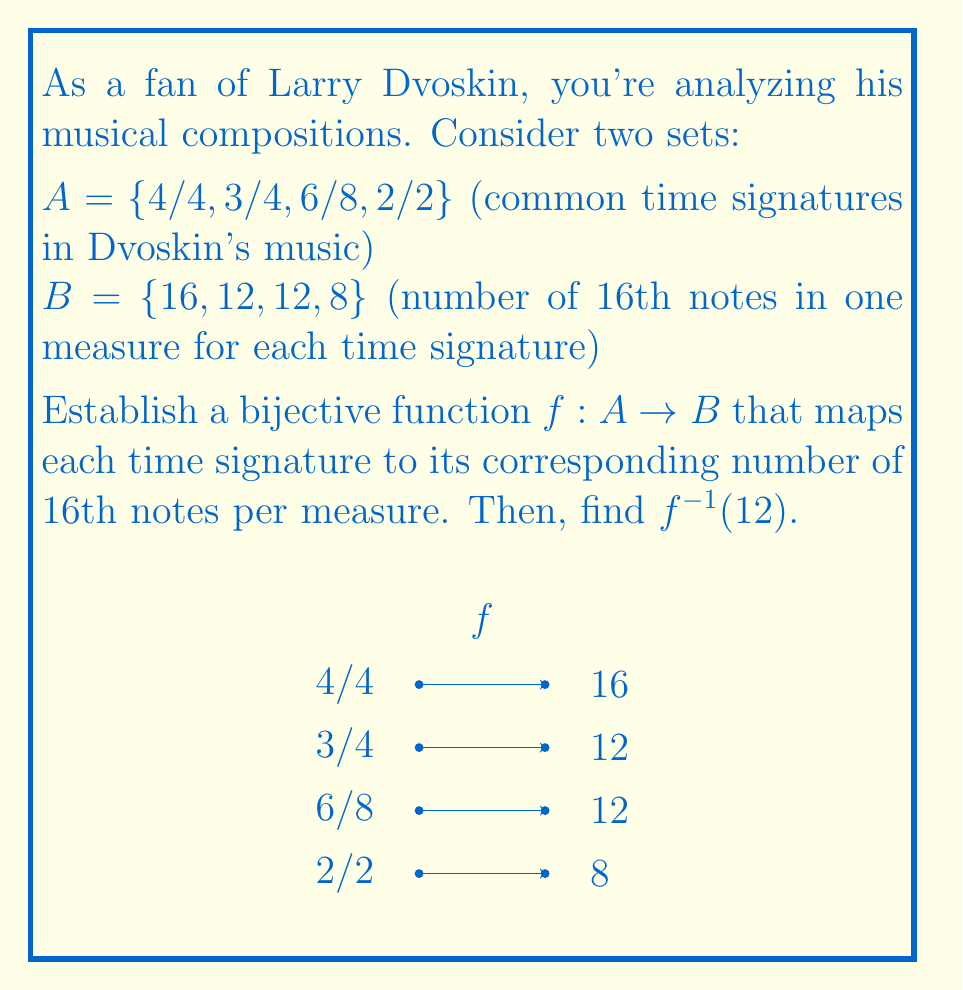Solve this math problem. To establish a bijective function between sets A and B, we need to map each element in A to a unique element in B. Let's break this down step-by-step:

1) First, let's define our function $f: A \rightarrow B$:

   $f(4/4) = 16$
   $f(3/4) = 12$
   $f(6/8) = 12$
   $f(2/2) = 8$

2) This function is bijective because:
   - It's injective (one-to-one): Each element in B is mapped to by at most one element in A.
   - It's surjective (onto): Every element in B is mapped to by at least one element in A.

3) To understand why this mapping works, let's break down each time signature:

   4/4: 4 quarter notes per measure, each quarter note = 4 sixteenth notes
        So, 4 * 4 = 16 sixteenth notes per measure

   3/4: 3 quarter notes per measure, each quarter note = 4 sixteenth notes
        So, 3 * 4 = 12 sixteenth notes per measure

   6/8: 6 eighth notes per measure, each eighth note = 2 sixteenth notes
        So, 6 * 2 = 12 sixteenth notes per measure

   2/2: 2 half notes per measure, each half note = 4 quarter notes = 16 sixteenth notes
        So, 2 * 4 = 8 sixteenth notes per measure

4) Now, to find $f^{-1}(12)$, we need to determine which time signature(s) map to 12 sixteenth notes per measure.

5) From our function definition, we can see that both 3/4 and 6/8 map to 12.

6) However, since $f^{-1}$ is a function (as $f$ is bijective), it must return a single value. In this case, we can choose either 3/4 or 6/8.

7) Let's choose 3/4 as our answer, noting that 6/8 would also be correct in a different context.
Answer: $f^{-1}(12) = 3/4$ 